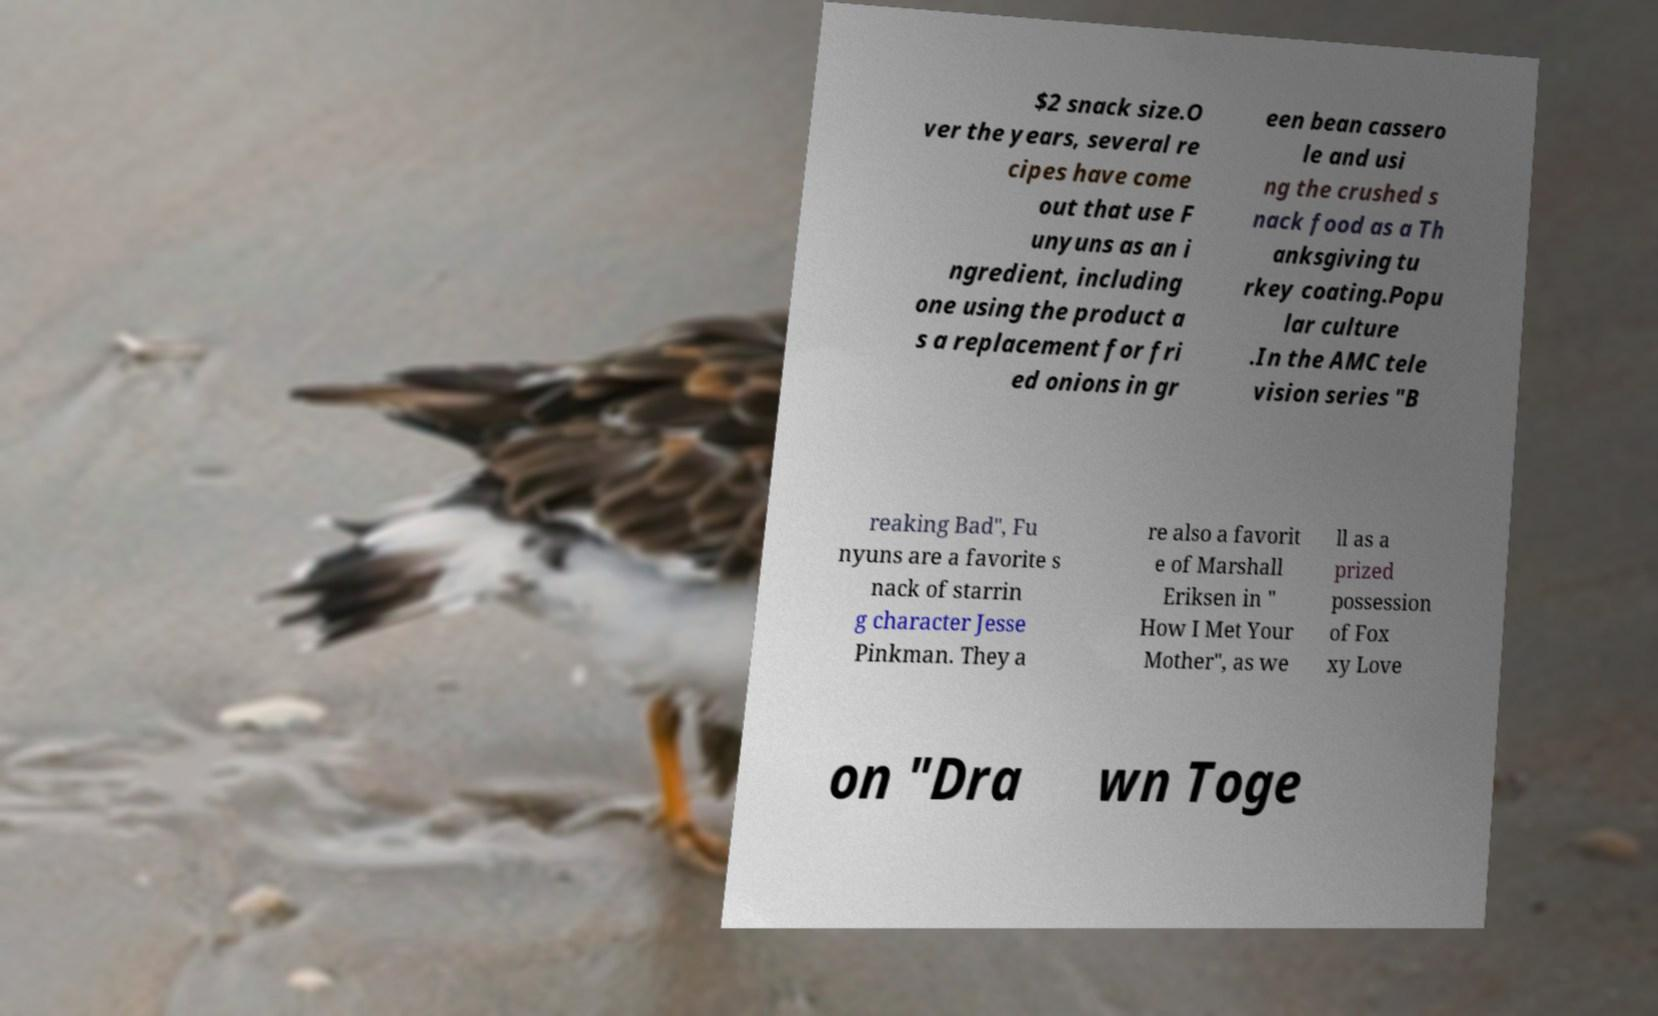Please read and relay the text visible in this image. What does it say? $2 snack size.O ver the years, several re cipes have come out that use F unyuns as an i ngredient, including one using the product a s a replacement for fri ed onions in gr een bean cassero le and usi ng the crushed s nack food as a Th anksgiving tu rkey coating.Popu lar culture .In the AMC tele vision series "B reaking Bad", Fu nyuns are a favorite s nack of starrin g character Jesse Pinkman. They a re also a favorit e of Marshall Eriksen in " How I Met Your Mother", as we ll as a prized possession of Fox xy Love on "Dra wn Toge 